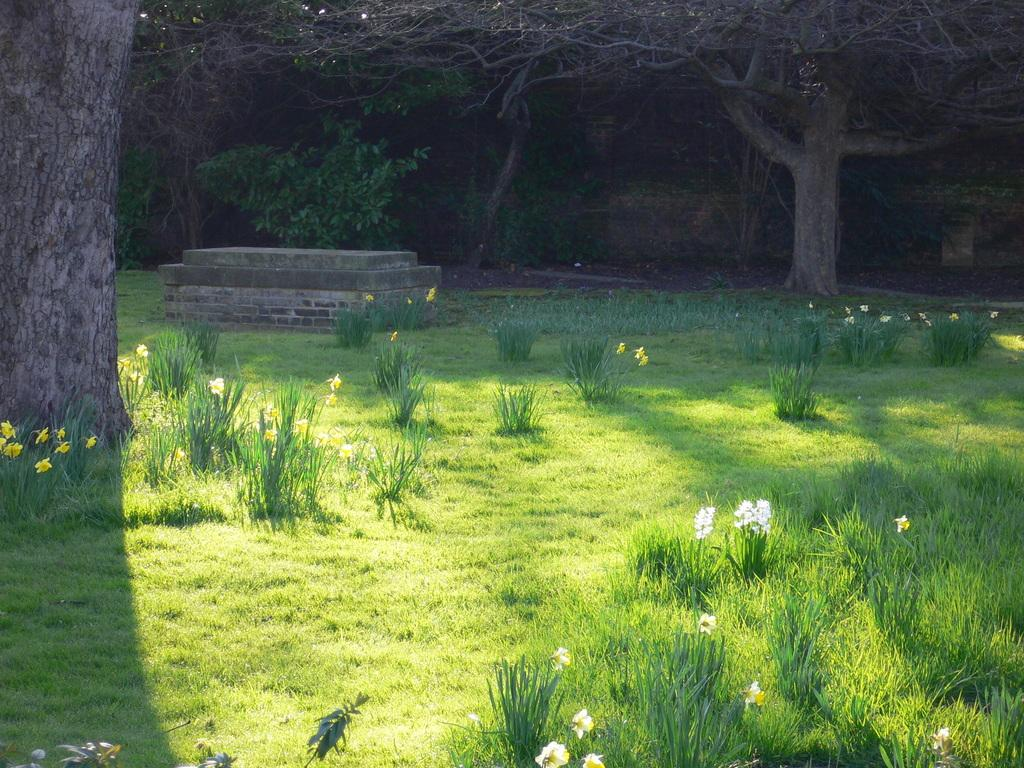What type of outdoor space is depicted in the image? There is a garden in the image. What can be found within the garden? There are beautiful flowers in the garden. What surrounds the garden in the image? There are many trees around the garden. How many units of balloons are tied to the trees in the image? There are no balloons present in the image, so it is not possible to determine the number of units tied to the trees. 